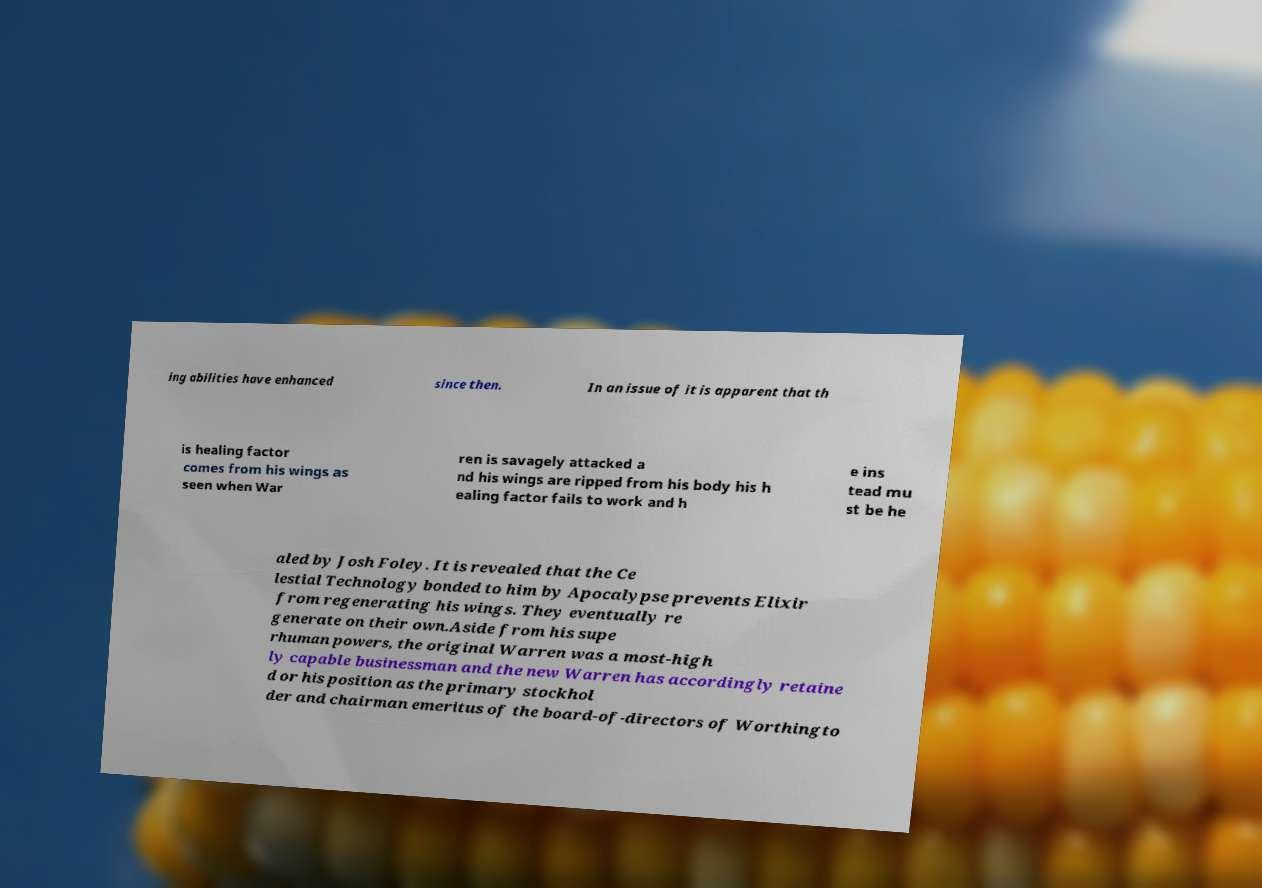What messages or text are displayed in this image? I need them in a readable, typed format. ing abilities have enhanced since then. In an issue of it is apparent that th is healing factor comes from his wings as seen when War ren is savagely attacked a nd his wings are ripped from his body his h ealing factor fails to work and h e ins tead mu st be he aled by Josh Foley. It is revealed that the Ce lestial Technology bonded to him by Apocalypse prevents Elixir from regenerating his wings. They eventually re generate on their own.Aside from his supe rhuman powers, the original Warren was a most-high ly capable businessman and the new Warren has accordingly retaine d or his position as the primary stockhol der and chairman emeritus of the board-of-directors of Worthingto 